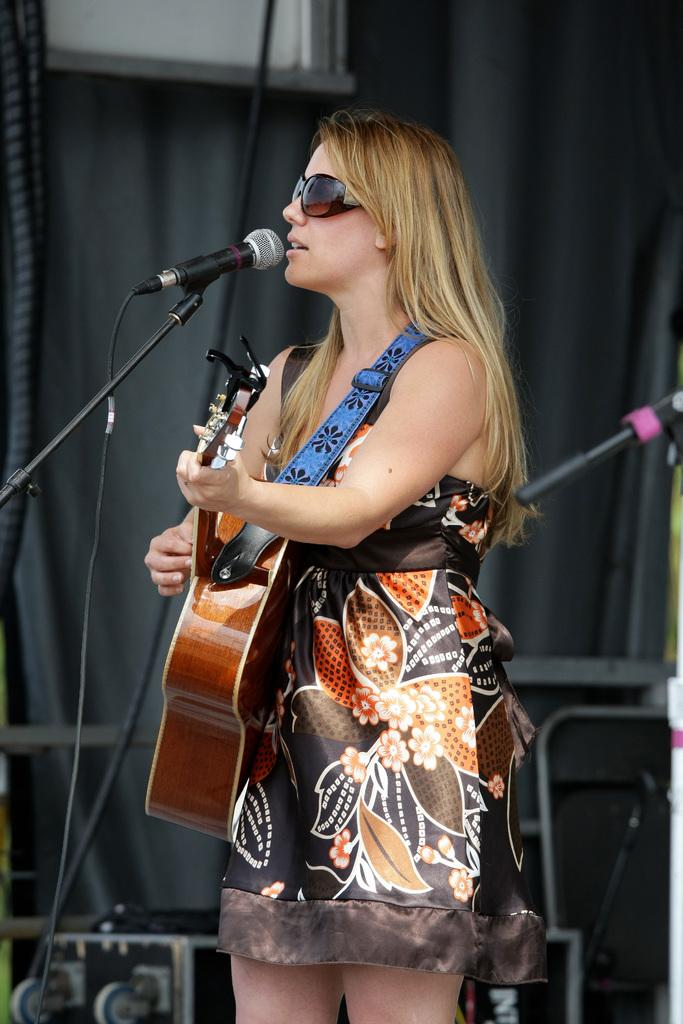Who is the main subject in the image? There is a woman in the image. What is the woman doing in the image? The woman is playing a guitar and singing on a mic. What type of pest can be seen crawling on the guitar in the image? There are no pests visible in the image, and the guitar is not being crawled on by any creature. 